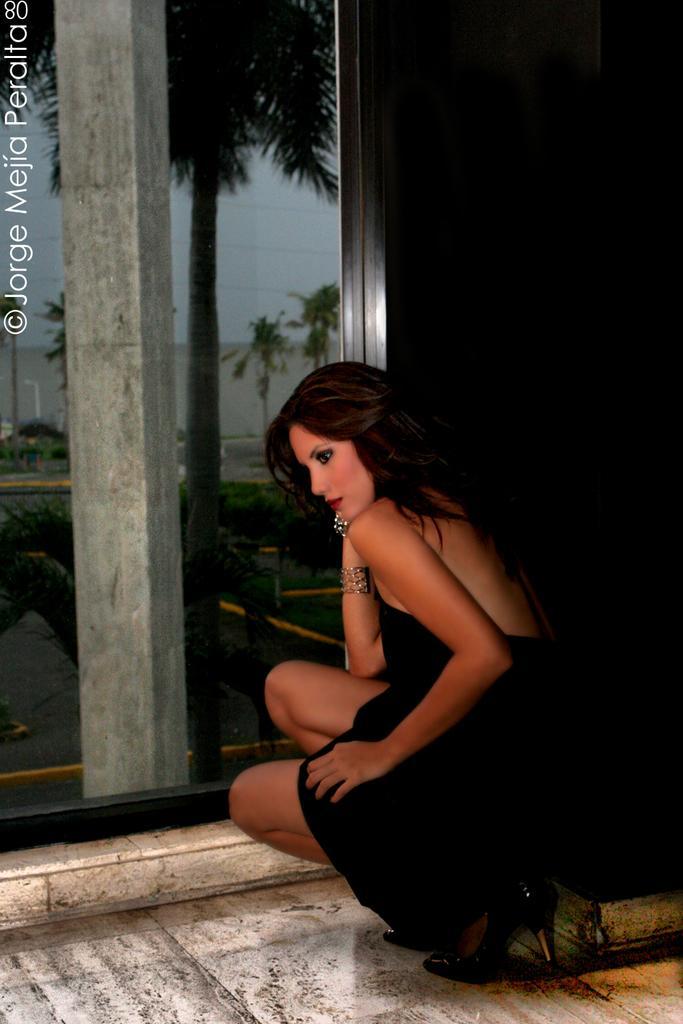Could you give a brief overview of what you see in this image? In the picture there is a woman sitting in a squat position in a glass window, through the glass window we can see trees, a wall and a clear sky. 